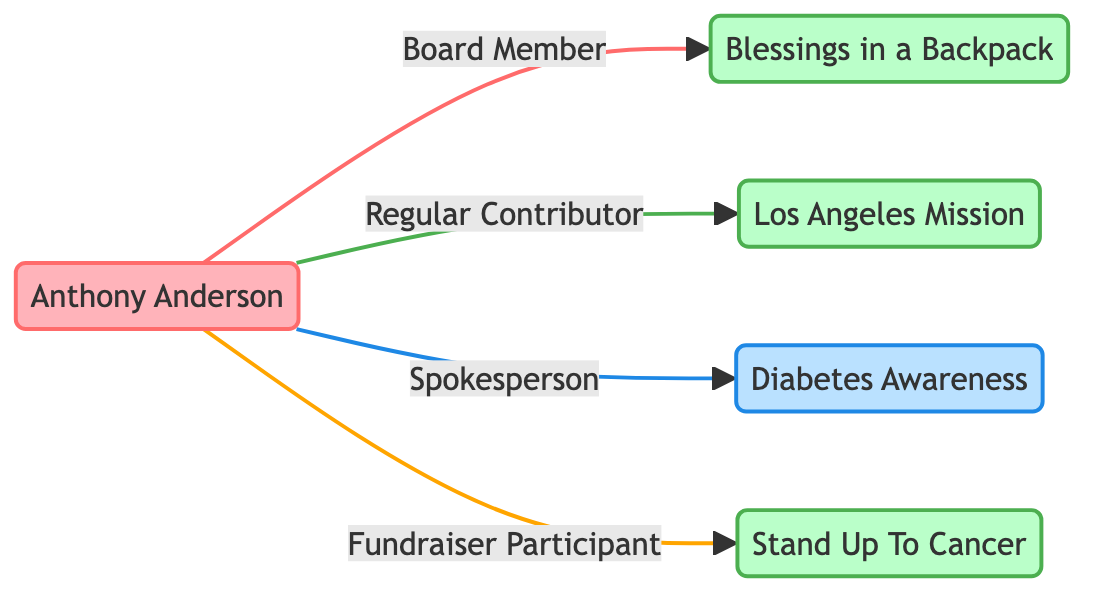What type of individual is Anthony Anderson? The visual information identifies Anthony Anderson as an "Individual" with the occupation of "Actor, Comedian". Thus, the answer is derived from the node type specification.
Answer: Individual How many charities are linked to Anthony Anderson? By counting the number of unique charity nodes that connect to Anthony Anderson, we find four distinct charities: Blessings in a Backpack, Los Angeles Mission, Stand Up To Cancer, and a health cause (Diabetes Awareness). The correspondence in the links confirms this count.
Answer: 4 What is Anthony Anderson's relationship with Stand Up To Cancer? The diagram directly shows that Anthony Anderson is a "Fundraiser Participant" in relation to the Stand Up To Cancer organization. This relationship is explicitly stated in the link.
Answer: Fundraiser Participant Which charity focuses on childhood hunger? From the nodes representing various charities, "Blessings in a Backpack" is explicitly designated as the charity that addresses "Childhood Hunger". This is derived from the details provided in that specific node.
Answer: Blessings in a Backpack What type of mission does the Los Angeles Mission have? The diagram indicates that the mission of the Los Angeles Mission is to "Provide help, hope, and opportunity to men, women, and children in need." This detail comes directly from the node's description.
Answer: Provide help, hope, and opportunity to men, women, and children in need Which organization has Anthony Anderson as a spokesperson? The link explicitly states that Anthony Anderson is the "Spokesperson" for "Diabetes Awareness", indicating his role in that particular cause. This information is directly referenced from the relationship chart.
Answer: Diabetes Awareness How many total nodes are present in the diagram? To find the total nodes, we can tally the unique entities represented. There are five nodes, consisting of one individual, four charities, and causes, yielding a sum.
Answer: 5 What is the focus area of Stand Up To Cancer? The node for Stand Up To Cancer specifies its focus area as "Cancer Research". This information is directly provided in the node's details, confirming its primary area of concern.
Answer: Cancer Research What is the relationship between Anthony Anderson and the Los Angeles Mission? The link indicates that Anthony Anderson's relationship with the Los Angeles Mission is described as a "Regular Contributor", directly referencing his engagement with that charity.
Answer: Regular Contributor 